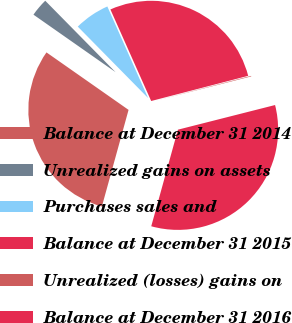Convert chart to OTSL. <chart><loc_0><loc_0><loc_500><loc_500><pie_chart><fcel>Balance at December 31 2014<fcel>Unrealized gains on assets<fcel>Purchases sales and<fcel>Balance at December 31 2015<fcel>Unrealized (losses) gains on<fcel>Balance at December 31 2016<nl><fcel>30.43%<fcel>2.9%<fcel>5.71%<fcel>27.62%<fcel>0.09%<fcel>33.24%<nl></chart> 